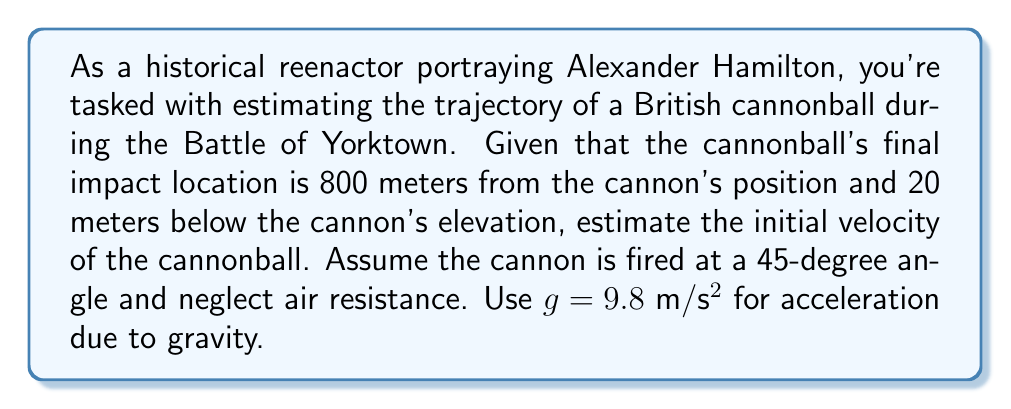Give your solution to this math problem. Let's approach this step-by-step:

1) The trajectory of a projectile (neglecting air resistance) is described by two equations:

   Horizontal motion: $x = v_0 \cos(\theta) t$
   Vertical motion: $y = v_0 \sin(\theta) t - \frac{1}{2}gt^2$

   Where $v_0$ is the initial velocity, $\theta$ is the launch angle, $t$ is time, and $g$ is acceleration due to gravity.

2) We're given:
   - $\theta = 45°$
   - Final $x = 800$ m
   - Final $y = -20$ m
   - $g = 9.8$ m/s²

3) For a 45° angle, $\cos(45°) = \sin(45°) = \frac{1}{\sqrt{2}}$

4) From the horizontal motion equation:
   $800 = v_0 \cdot \frac{1}{\sqrt{2}} \cdot t$
   $t = \frac{800\sqrt{2}}{v_0}$

5) Substitute this into the vertical motion equation:
   $-20 = v_0 \cdot \frac{1}{\sqrt{2}} \cdot \frac{800\sqrt{2}}{v_0} - \frac{1}{2} \cdot 9.8 \cdot (\frac{800\sqrt{2}}{v_0})^2$

6) Simplify:
   $-20 = 800 - \frac{3136000}{v_0^2}$

7) Solve for $v_0$:
   $\frac{3136000}{v_0^2} = 820$
   $v_0^2 = \frac{3136000}{820} = 3824.39$
   $v_0 = \sqrt{3824.39} \approx 61.84$ m/s

Therefore, the initial velocity of the cannonball was approximately 61.84 m/s.
Answer: 61.84 m/s 